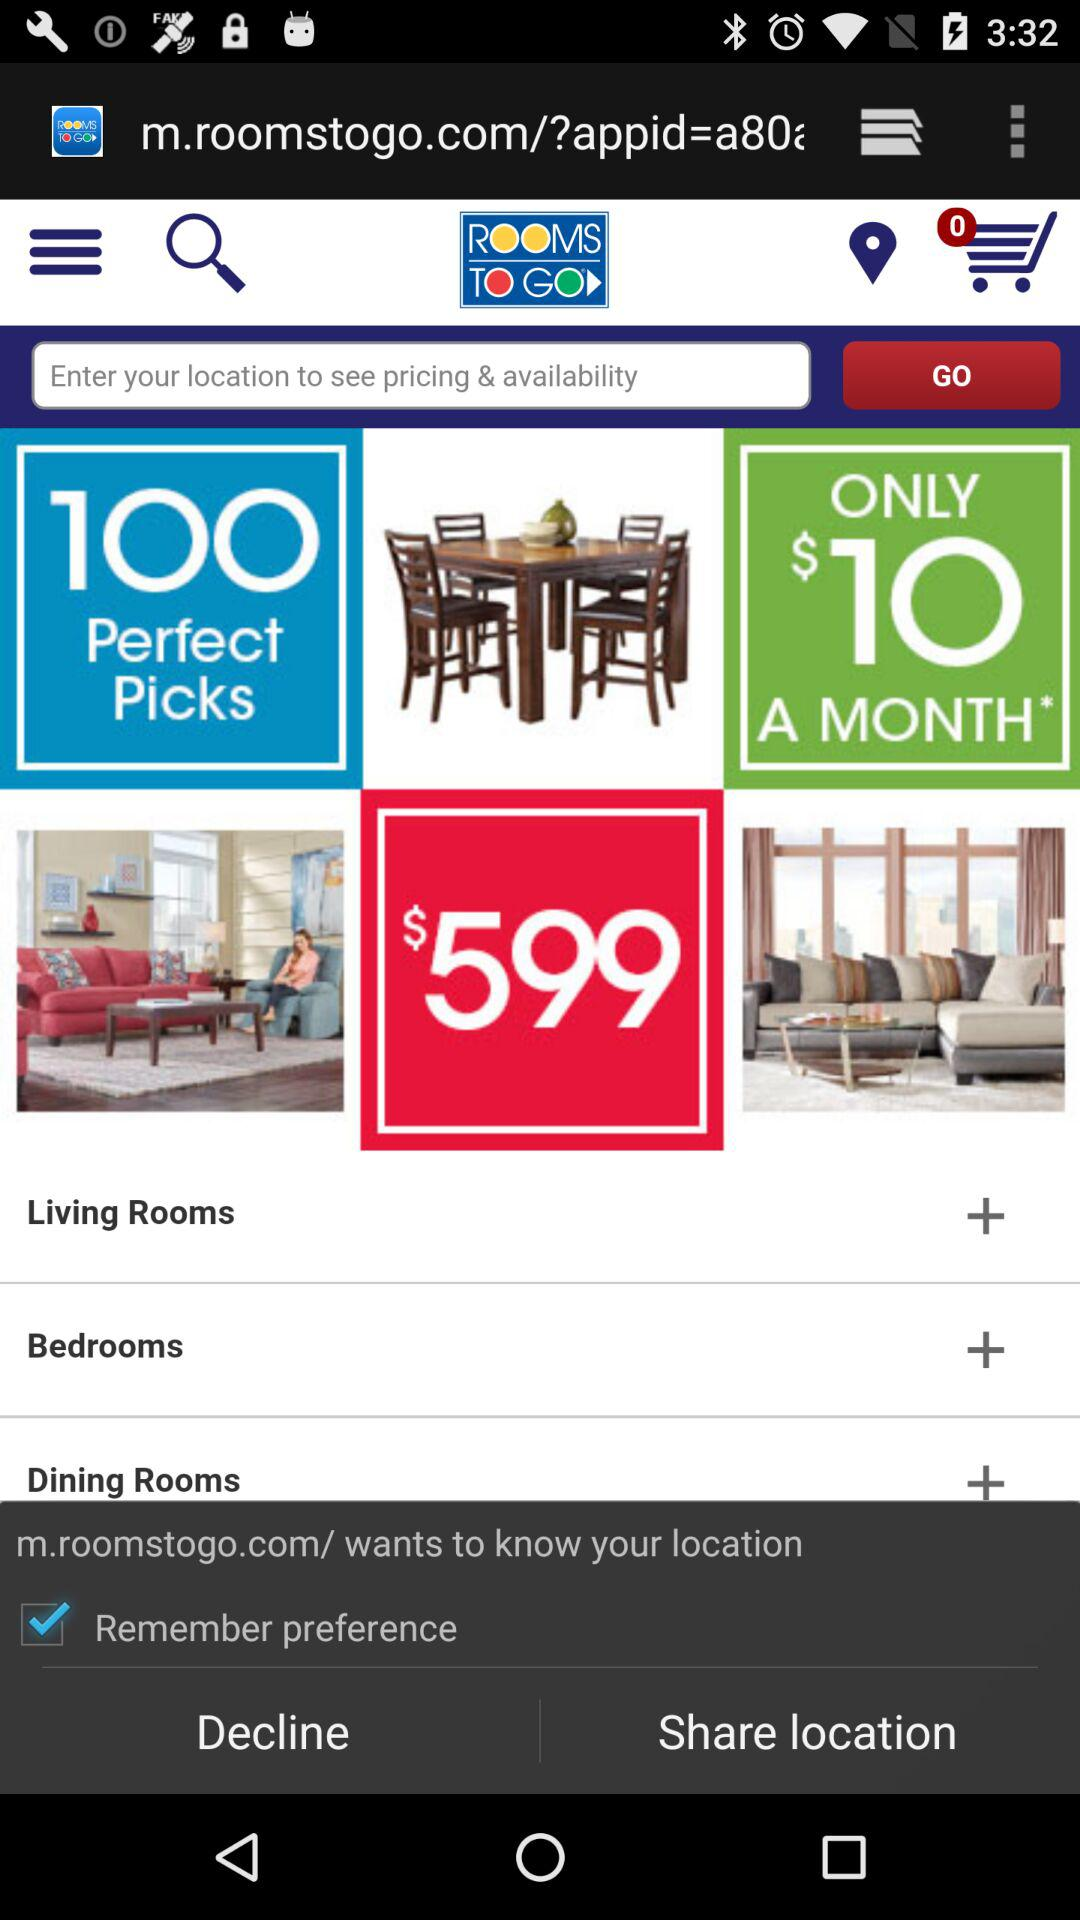How many dollars will it cost for one month? It will cost $10 for one month. 